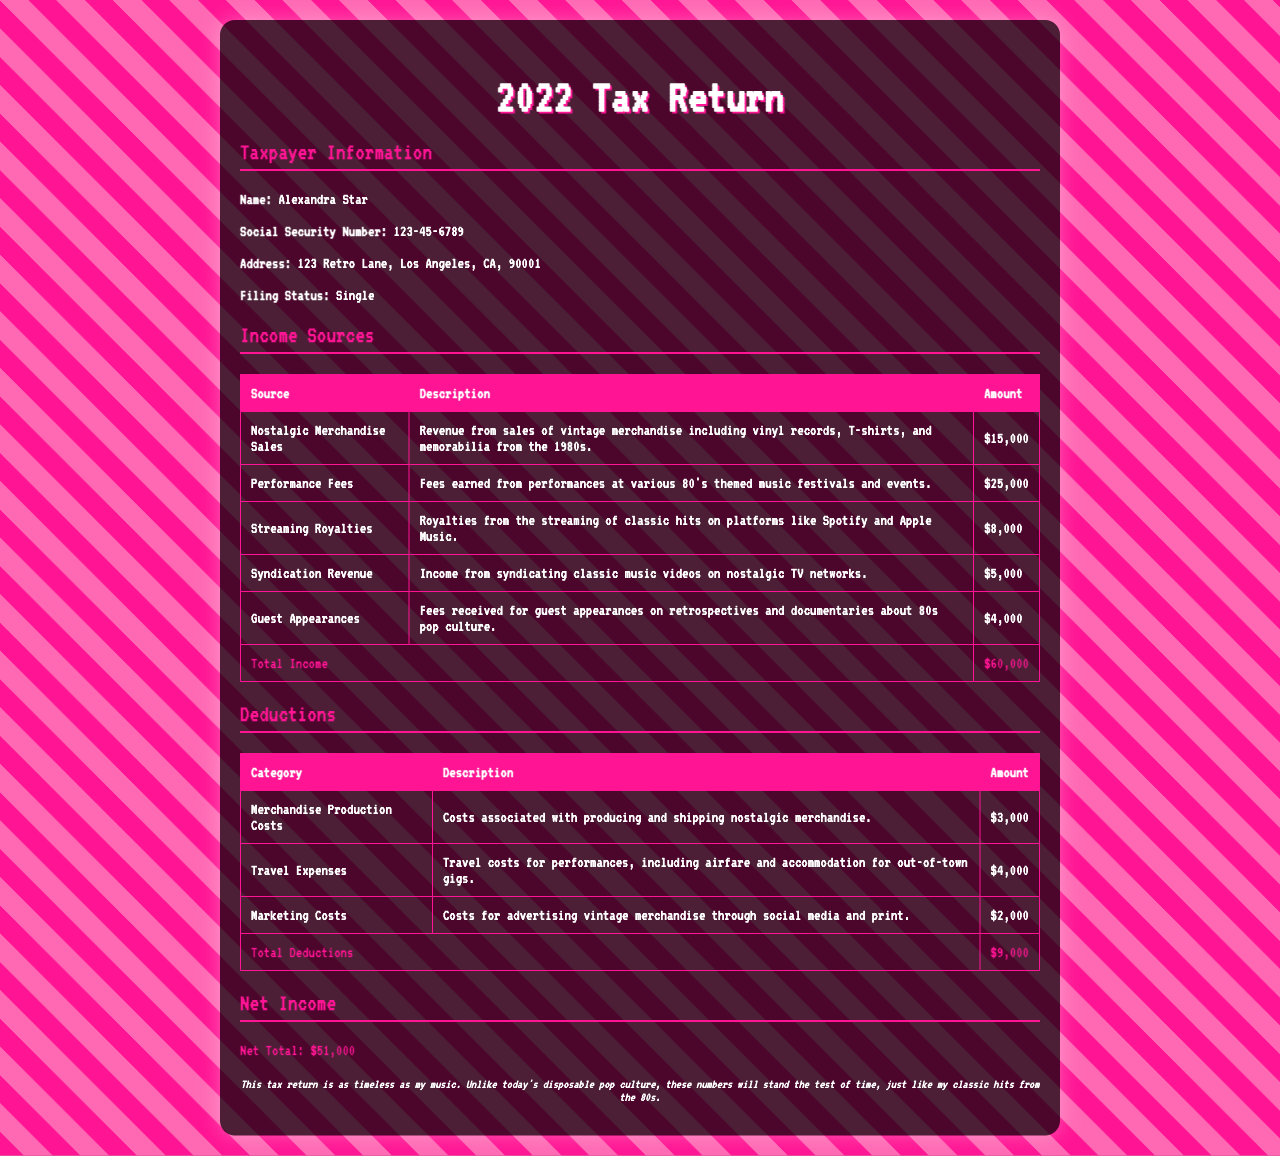What is the taxpayer's name? The document specifies the name of the taxpayer as Alexandra Star.
Answer: Alexandra Star What is the total income listed in the tax return? The total income is calculated by adding all income sources together, which is $15,000 + $25,000 + $8,000 + $5,000 + $4,000 = $60,000.
Answer: $60,000 What is the amount for performance fees? The section on income sources lists performance fees as earning $25,000.
Answer: $25,000 What category has the highest amount of deductions? The table reveals that travel expenses amount to $4,000, which is the highest deduction listed.
Answer: Travel Expenses What is the net income reported? The net income is indicated as the total income minus total deductions, which is $60,000 - $9,000 = $51,000.
Answer: $51,000 How much was earned from nostalgic merchandise sales? The income source for nostalgic merchandise sales indicates an amount of $15,000.
Answer: $15,000 What is the address of the taxpayer? The document provides the full address as 123 Retro Lane, Los Angeles, CA, 90001.
Answer: 123 Retro Lane, Los Angeles, CA, 90001 What are guest appearances classified under in income sources? The document categorizes guest appearances under income sources, detailing the fees received for those appearances as $4,000.
Answer: Guest Appearances What is the total amount for merchandise production costs? The deductions section states that merchandise production costs amount to $3,000.
Answer: $3,000 